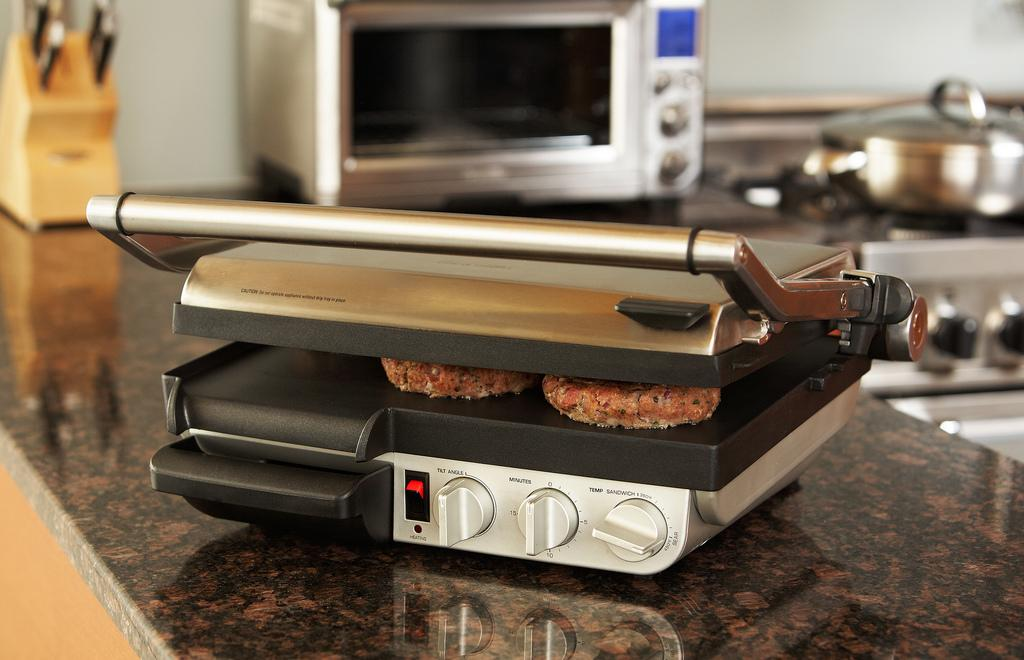Provide a one-sentence caption for the provided image. A silver pressed down grill with the timer set at 0. 